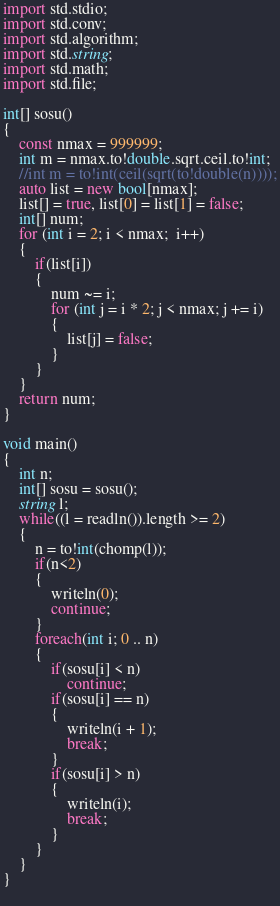Convert code to text. <code><loc_0><loc_0><loc_500><loc_500><_D_>import std.stdio;
import std.conv;
import std.algorithm;
import std.string;
import std.math;
import std.file;
  
int[] sosu() 
{
	const nmax = 999999;
	int m = nmax.to!double.sqrt.ceil.to!int;
	//int m = to!int(ceil(sqrt(to!double(n))));
	auto list = new bool[nmax];
	list[] = true, list[0] = list[1] = false;
	int[] num;
	for (int i = 2; i < nmax;  i++)
	{
		if(list[i])
		{
			num ~= i;
			for (int j = i * 2; j < nmax; j += i)
			{
				list[j] = false;
			}
		}
	}
    return num;
}

void main()
{
	int n;
	int[] sosu = sosu();
	string l;
	while((l = readln()).length >= 2)
	{
		n = to!int(chomp(l));
		if(n<2)
		{
			writeln(0);
			continue;
		}
		foreach(int i; 0 .. n)
		{
			if(sosu[i] < n)
				continue;
			if(sosu[i] == n)
			{
				writeln(i + 1);
				break;
			}
			if(sosu[i] > n)
			{
				writeln(i);
				break;
			}
		}
	}
}
		</code> 